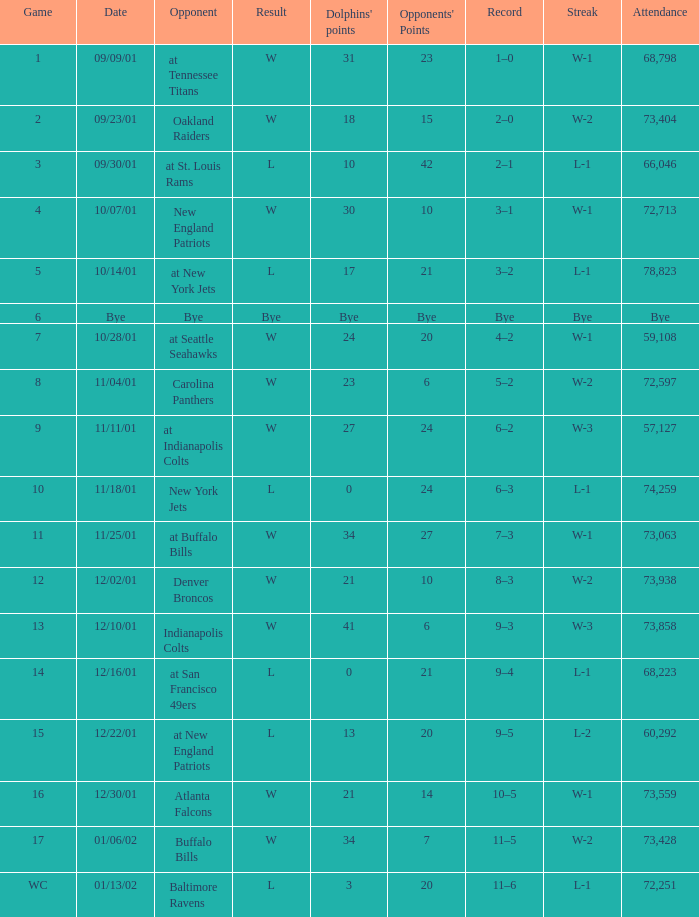How many attended the game with an opponent of bye? Bye. 